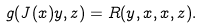<formula> <loc_0><loc_0><loc_500><loc_500>g ( J ( x ) y , z ) = R ( y , x , x , z ) .</formula> 